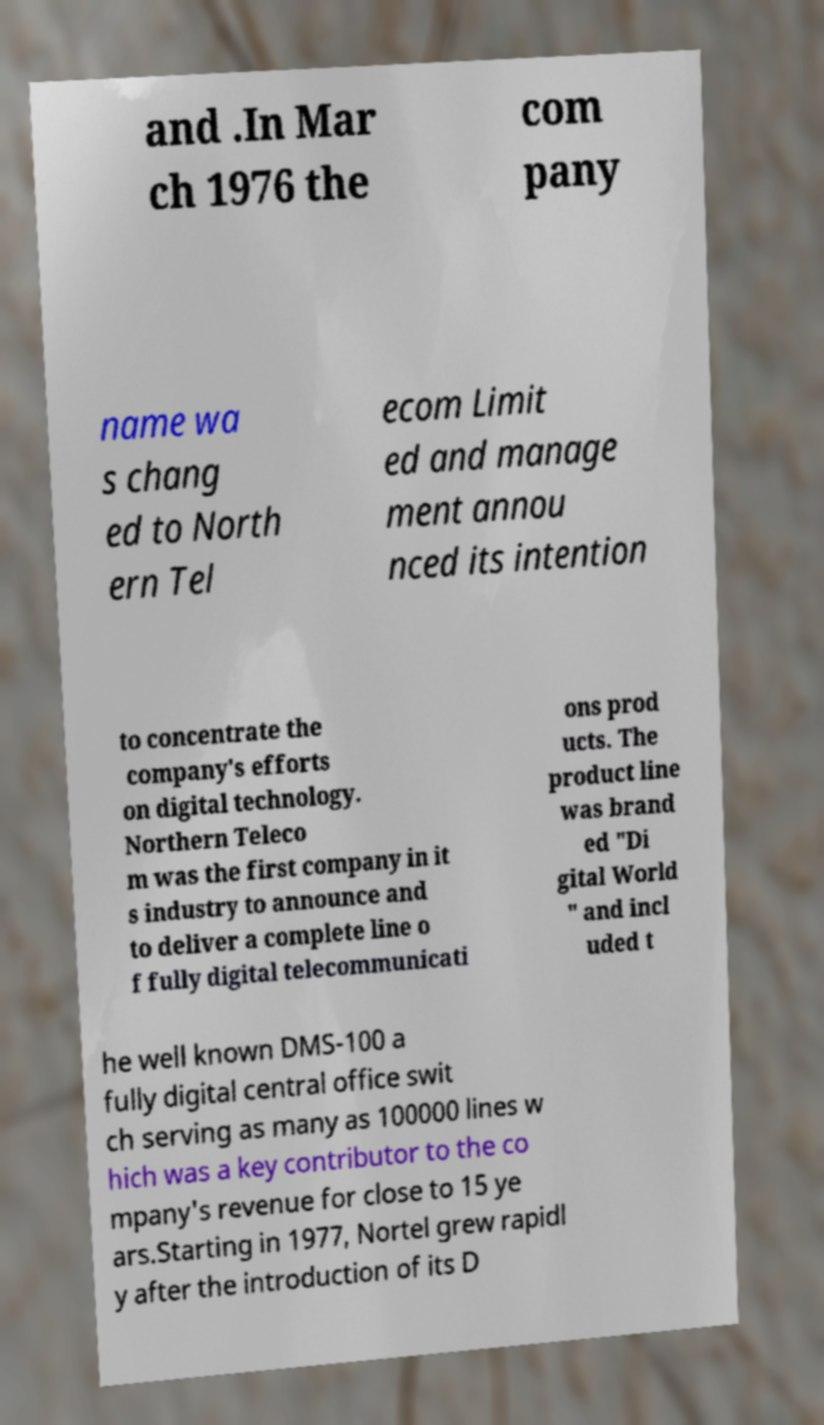Please identify and transcribe the text found in this image. and .In Mar ch 1976 the com pany name wa s chang ed to North ern Tel ecom Limit ed and manage ment annou nced its intention to concentrate the company's efforts on digital technology. Northern Teleco m was the first company in it s industry to announce and to deliver a complete line o f fully digital telecommunicati ons prod ucts. The product line was brand ed "Di gital World " and incl uded t he well known DMS-100 a fully digital central office swit ch serving as many as 100000 lines w hich was a key contributor to the co mpany's revenue for close to 15 ye ars.Starting in 1977, Nortel grew rapidl y after the introduction of its D 